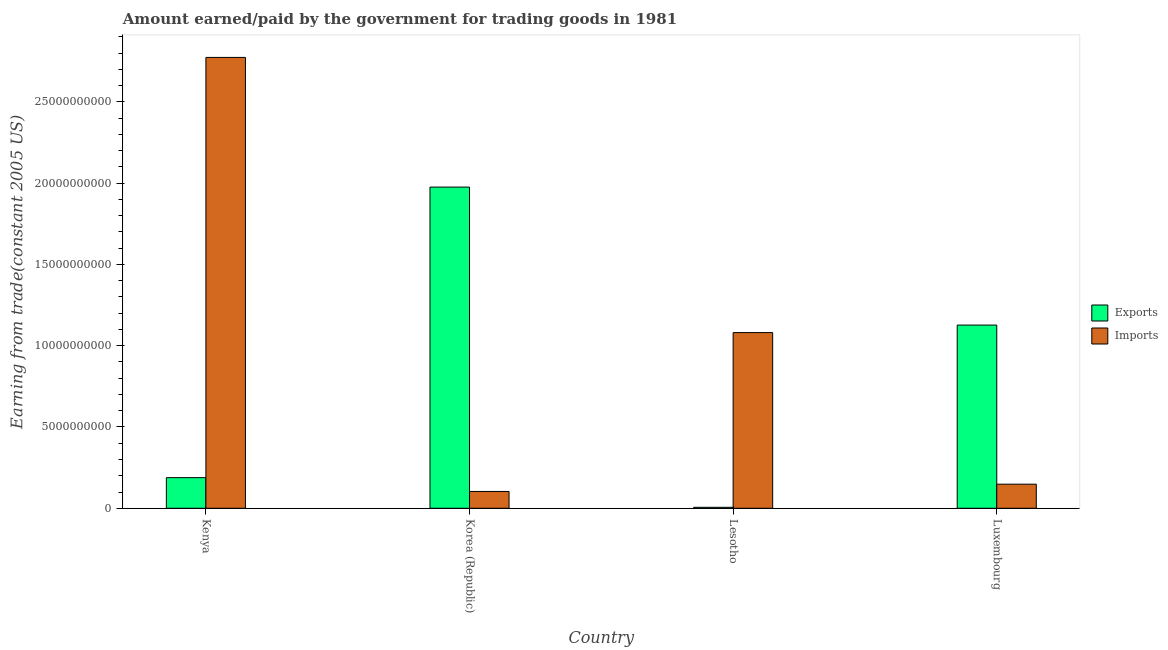How many different coloured bars are there?
Keep it short and to the point. 2. Are the number of bars per tick equal to the number of legend labels?
Your answer should be compact. Yes. How many bars are there on the 4th tick from the left?
Offer a terse response. 2. How many bars are there on the 3rd tick from the right?
Offer a terse response. 2. What is the label of the 1st group of bars from the left?
Provide a succinct answer. Kenya. What is the amount earned from exports in Luxembourg?
Ensure brevity in your answer.  1.13e+1. Across all countries, what is the maximum amount earned from exports?
Provide a succinct answer. 1.98e+1. Across all countries, what is the minimum amount paid for imports?
Your answer should be compact. 1.03e+09. What is the total amount earned from exports in the graph?
Make the answer very short. 3.30e+1. What is the difference between the amount paid for imports in Korea (Republic) and that in Luxembourg?
Provide a short and direct response. -4.48e+08. What is the difference between the amount earned from exports in Kenya and the amount paid for imports in Luxembourg?
Ensure brevity in your answer.  4.01e+08. What is the average amount paid for imports per country?
Make the answer very short. 1.03e+1. What is the difference between the amount paid for imports and amount earned from exports in Lesotho?
Provide a short and direct response. 1.07e+1. What is the ratio of the amount paid for imports in Lesotho to that in Luxembourg?
Provide a short and direct response. 7.29. Is the amount earned from exports in Kenya less than that in Lesotho?
Your answer should be very brief. No. What is the difference between the highest and the second highest amount paid for imports?
Make the answer very short. 1.69e+1. What is the difference between the highest and the lowest amount paid for imports?
Your response must be concise. 2.67e+1. In how many countries, is the amount paid for imports greater than the average amount paid for imports taken over all countries?
Offer a very short reply. 2. What does the 2nd bar from the left in Korea (Republic) represents?
Offer a terse response. Imports. What does the 1st bar from the right in Kenya represents?
Your response must be concise. Imports. Does the graph contain any zero values?
Provide a succinct answer. No. Does the graph contain grids?
Make the answer very short. No. Where does the legend appear in the graph?
Offer a terse response. Center right. How are the legend labels stacked?
Offer a terse response. Vertical. What is the title of the graph?
Your answer should be compact. Amount earned/paid by the government for trading goods in 1981. Does "Enforce a contract" appear as one of the legend labels in the graph?
Your answer should be very brief. No. What is the label or title of the X-axis?
Provide a succinct answer. Country. What is the label or title of the Y-axis?
Provide a short and direct response. Earning from trade(constant 2005 US). What is the Earning from trade(constant 2005 US) of Exports in Kenya?
Keep it short and to the point. 1.88e+09. What is the Earning from trade(constant 2005 US) of Imports in Kenya?
Offer a very short reply. 2.77e+1. What is the Earning from trade(constant 2005 US) in Exports in Korea (Republic)?
Your response must be concise. 1.98e+1. What is the Earning from trade(constant 2005 US) in Imports in Korea (Republic)?
Give a very brief answer. 1.03e+09. What is the Earning from trade(constant 2005 US) of Exports in Lesotho?
Your answer should be very brief. 5.93e+07. What is the Earning from trade(constant 2005 US) of Imports in Lesotho?
Make the answer very short. 1.08e+1. What is the Earning from trade(constant 2005 US) in Exports in Luxembourg?
Ensure brevity in your answer.  1.13e+1. What is the Earning from trade(constant 2005 US) in Imports in Luxembourg?
Offer a terse response. 1.48e+09. Across all countries, what is the maximum Earning from trade(constant 2005 US) in Exports?
Offer a very short reply. 1.98e+1. Across all countries, what is the maximum Earning from trade(constant 2005 US) of Imports?
Offer a very short reply. 2.77e+1. Across all countries, what is the minimum Earning from trade(constant 2005 US) of Exports?
Ensure brevity in your answer.  5.93e+07. Across all countries, what is the minimum Earning from trade(constant 2005 US) in Imports?
Give a very brief answer. 1.03e+09. What is the total Earning from trade(constant 2005 US) of Exports in the graph?
Ensure brevity in your answer.  3.30e+1. What is the total Earning from trade(constant 2005 US) in Imports in the graph?
Make the answer very short. 4.11e+1. What is the difference between the Earning from trade(constant 2005 US) of Exports in Kenya and that in Korea (Republic)?
Offer a terse response. -1.79e+1. What is the difference between the Earning from trade(constant 2005 US) of Imports in Kenya and that in Korea (Republic)?
Keep it short and to the point. 2.67e+1. What is the difference between the Earning from trade(constant 2005 US) of Exports in Kenya and that in Lesotho?
Give a very brief answer. 1.82e+09. What is the difference between the Earning from trade(constant 2005 US) of Imports in Kenya and that in Lesotho?
Offer a very short reply. 1.69e+1. What is the difference between the Earning from trade(constant 2005 US) of Exports in Kenya and that in Luxembourg?
Give a very brief answer. -9.39e+09. What is the difference between the Earning from trade(constant 2005 US) of Imports in Kenya and that in Luxembourg?
Your answer should be very brief. 2.63e+1. What is the difference between the Earning from trade(constant 2005 US) of Exports in Korea (Republic) and that in Lesotho?
Make the answer very short. 1.97e+1. What is the difference between the Earning from trade(constant 2005 US) of Imports in Korea (Republic) and that in Lesotho?
Your answer should be compact. -9.77e+09. What is the difference between the Earning from trade(constant 2005 US) of Exports in Korea (Republic) and that in Luxembourg?
Keep it short and to the point. 8.49e+09. What is the difference between the Earning from trade(constant 2005 US) of Imports in Korea (Republic) and that in Luxembourg?
Make the answer very short. -4.48e+08. What is the difference between the Earning from trade(constant 2005 US) of Exports in Lesotho and that in Luxembourg?
Make the answer very short. -1.12e+1. What is the difference between the Earning from trade(constant 2005 US) of Imports in Lesotho and that in Luxembourg?
Ensure brevity in your answer.  9.33e+09. What is the difference between the Earning from trade(constant 2005 US) of Exports in Kenya and the Earning from trade(constant 2005 US) of Imports in Korea (Republic)?
Provide a short and direct response. 8.49e+08. What is the difference between the Earning from trade(constant 2005 US) in Exports in Kenya and the Earning from trade(constant 2005 US) in Imports in Lesotho?
Keep it short and to the point. -8.92e+09. What is the difference between the Earning from trade(constant 2005 US) of Exports in Kenya and the Earning from trade(constant 2005 US) of Imports in Luxembourg?
Make the answer very short. 4.01e+08. What is the difference between the Earning from trade(constant 2005 US) in Exports in Korea (Republic) and the Earning from trade(constant 2005 US) in Imports in Lesotho?
Give a very brief answer. 8.95e+09. What is the difference between the Earning from trade(constant 2005 US) of Exports in Korea (Republic) and the Earning from trade(constant 2005 US) of Imports in Luxembourg?
Make the answer very short. 1.83e+1. What is the difference between the Earning from trade(constant 2005 US) of Exports in Lesotho and the Earning from trade(constant 2005 US) of Imports in Luxembourg?
Offer a terse response. -1.42e+09. What is the average Earning from trade(constant 2005 US) in Exports per country?
Your answer should be compact. 8.24e+09. What is the average Earning from trade(constant 2005 US) of Imports per country?
Provide a succinct answer. 1.03e+1. What is the difference between the Earning from trade(constant 2005 US) in Exports and Earning from trade(constant 2005 US) in Imports in Kenya?
Offer a terse response. -2.59e+1. What is the difference between the Earning from trade(constant 2005 US) of Exports and Earning from trade(constant 2005 US) of Imports in Korea (Republic)?
Keep it short and to the point. 1.87e+1. What is the difference between the Earning from trade(constant 2005 US) of Exports and Earning from trade(constant 2005 US) of Imports in Lesotho?
Your response must be concise. -1.07e+1. What is the difference between the Earning from trade(constant 2005 US) in Exports and Earning from trade(constant 2005 US) in Imports in Luxembourg?
Provide a succinct answer. 9.79e+09. What is the ratio of the Earning from trade(constant 2005 US) in Exports in Kenya to that in Korea (Republic)?
Your response must be concise. 0.1. What is the ratio of the Earning from trade(constant 2005 US) in Imports in Kenya to that in Korea (Republic)?
Your answer should be compact. 26.82. What is the ratio of the Earning from trade(constant 2005 US) of Exports in Kenya to that in Lesotho?
Give a very brief answer. 31.79. What is the ratio of the Earning from trade(constant 2005 US) in Imports in Kenya to that in Lesotho?
Your response must be concise. 2.57. What is the ratio of the Earning from trade(constant 2005 US) of Exports in Kenya to that in Luxembourg?
Provide a succinct answer. 0.17. What is the ratio of the Earning from trade(constant 2005 US) of Imports in Kenya to that in Luxembourg?
Provide a succinct answer. 18.71. What is the ratio of the Earning from trade(constant 2005 US) in Exports in Korea (Republic) to that in Lesotho?
Keep it short and to the point. 333.45. What is the ratio of the Earning from trade(constant 2005 US) of Imports in Korea (Republic) to that in Lesotho?
Your answer should be compact. 0.1. What is the ratio of the Earning from trade(constant 2005 US) of Exports in Korea (Republic) to that in Luxembourg?
Offer a terse response. 1.75. What is the ratio of the Earning from trade(constant 2005 US) of Imports in Korea (Republic) to that in Luxembourg?
Your answer should be compact. 0.7. What is the ratio of the Earning from trade(constant 2005 US) of Exports in Lesotho to that in Luxembourg?
Make the answer very short. 0.01. What is the ratio of the Earning from trade(constant 2005 US) in Imports in Lesotho to that in Luxembourg?
Your answer should be compact. 7.29. What is the difference between the highest and the second highest Earning from trade(constant 2005 US) in Exports?
Your response must be concise. 8.49e+09. What is the difference between the highest and the second highest Earning from trade(constant 2005 US) in Imports?
Your answer should be very brief. 1.69e+1. What is the difference between the highest and the lowest Earning from trade(constant 2005 US) in Exports?
Keep it short and to the point. 1.97e+1. What is the difference between the highest and the lowest Earning from trade(constant 2005 US) in Imports?
Give a very brief answer. 2.67e+1. 